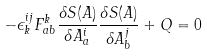<formula> <loc_0><loc_0><loc_500><loc_500>- \epsilon ^ { i j } _ { k } F ^ { k } _ { a b } \frac { \delta S ( A ) } { \delta A _ { a } ^ { i } } \frac { \delta S ( A ) } { \delta A _ { b } ^ { j } } + Q = 0</formula> 